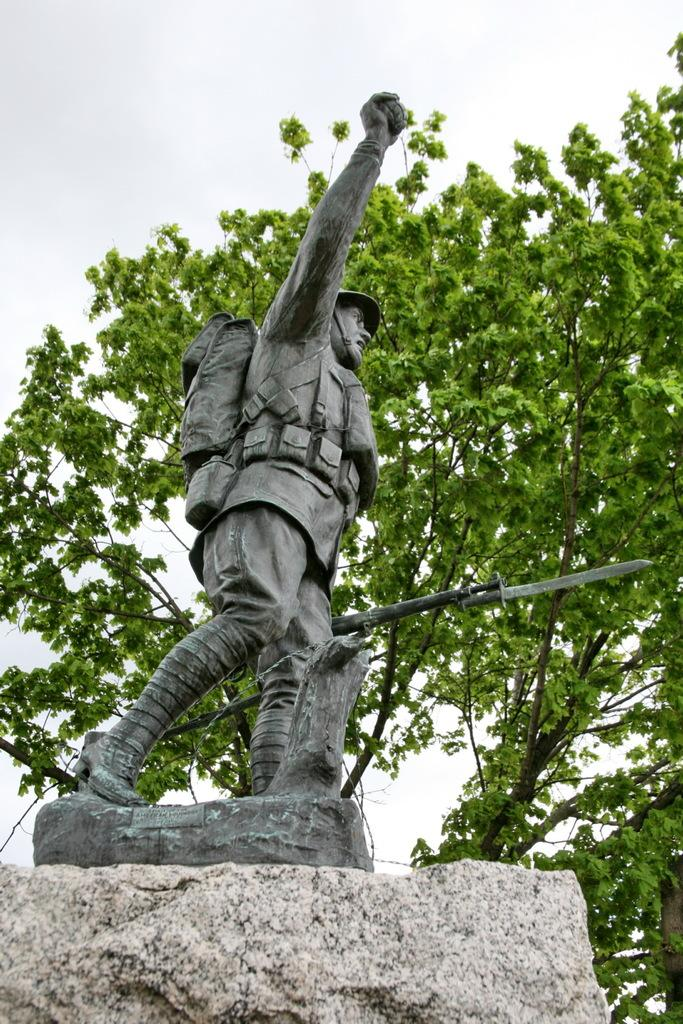What is the main subject in the image? There is a statue in the image. Where is the statue located? The statue is on a rock. What can be seen in the background of the image? There are trees and the sky visible in the background of the image. What type of knee injury can be seen on the statue in the image? There is no knee injury present on the statue in the image. 